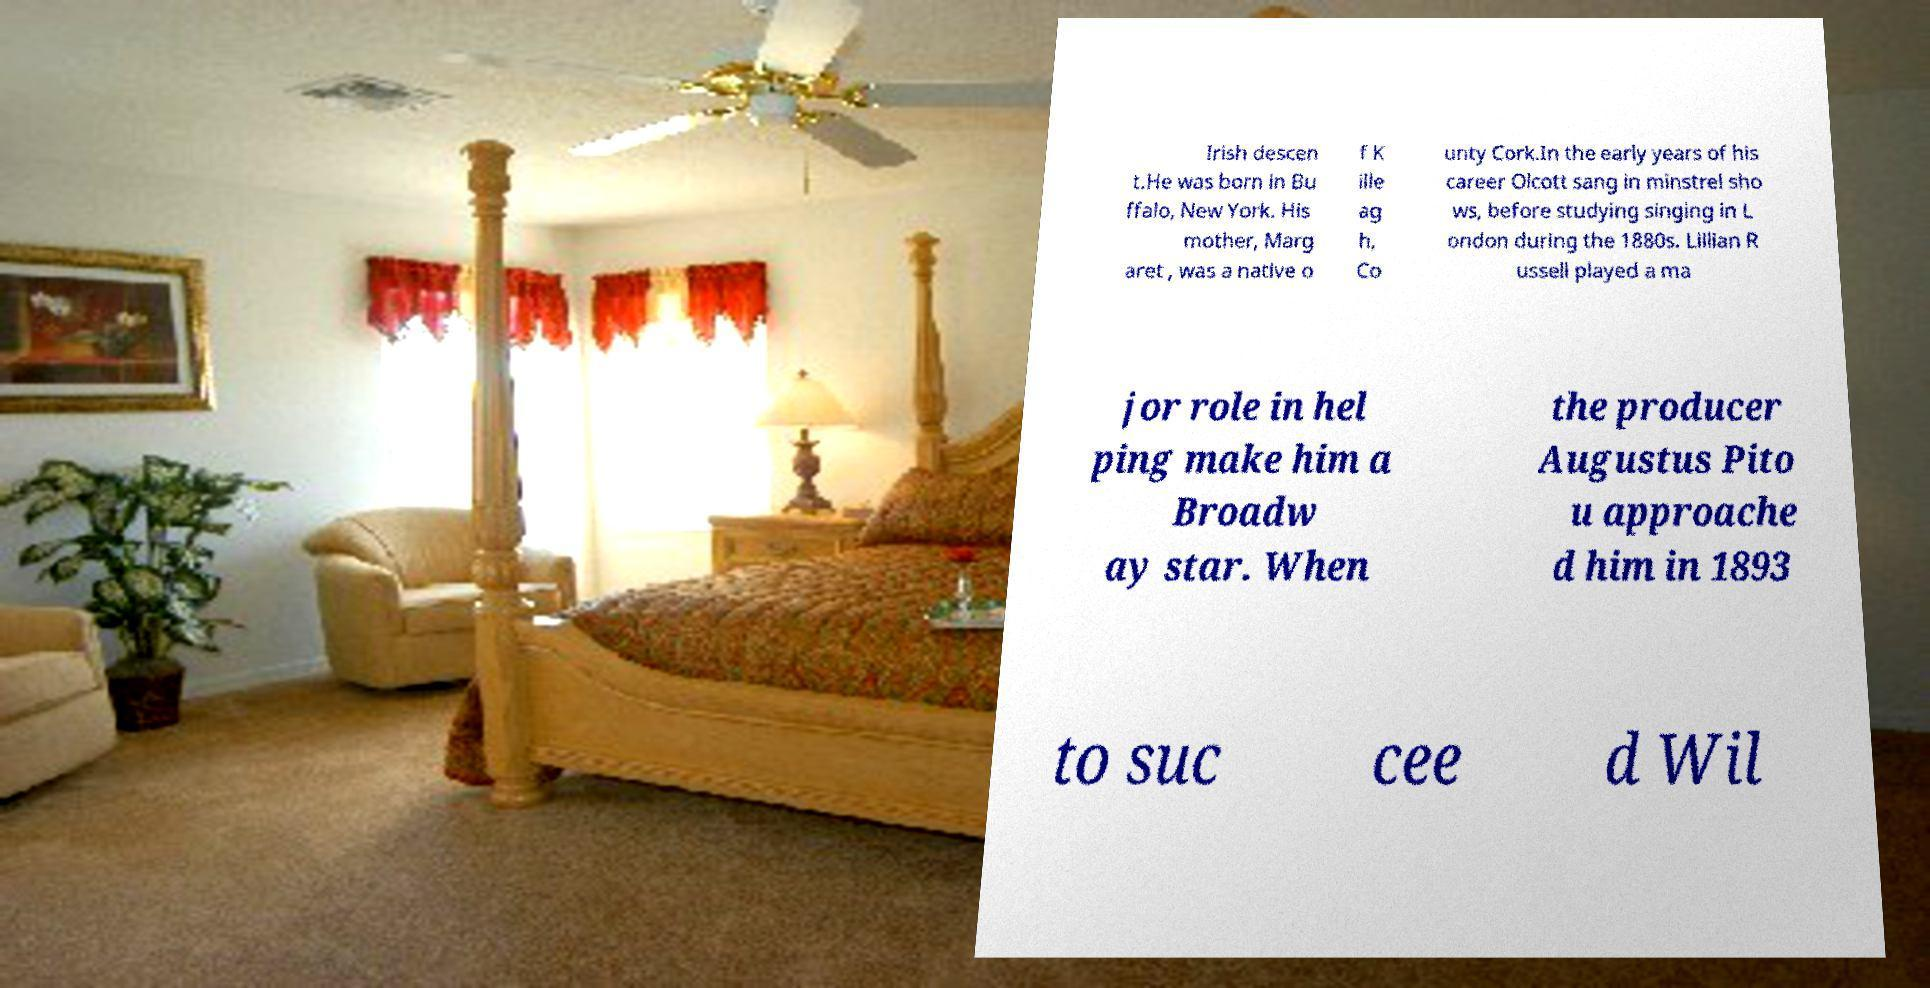Could you extract and type out the text from this image? Irish descen t.He was born in Bu ffalo, New York. His mother, Marg aret , was a native o f K ille ag h, Co unty Cork.In the early years of his career Olcott sang in minstrel sho ws, before studying singing in L ondon during the 1880s. Lillian R ussell played a ma jor role in hel ping make him a Broadw ay star. When the producer Augustus Pito u approache d him in 1893 to suc cee d Wil 